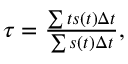Convert formula to latex. <formula><loc_0><loc_0><loc_500><loc_500>\begin{array} { r } { \tau = \frac { \sum t s ( t ) \Delta t } { \sum s ( t ) \Delta t } , } \end{array}</formula> 